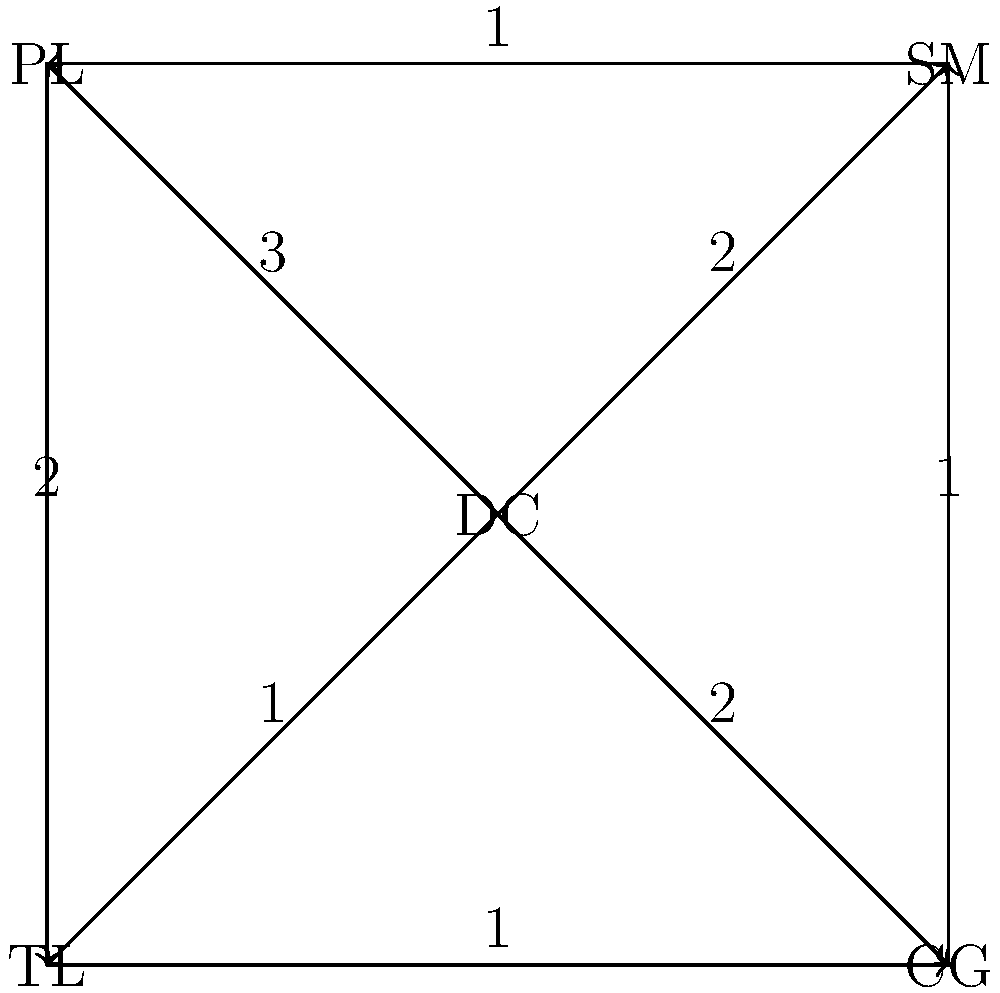In this sociogram representing communication flow in a marching band, nodes represent different sections (DC: Drum Captain, SM: Section Manager, PL: Percussion Lead, TL: Trumpet Lead, CG: Color Guard), and edges represent the frequency of interactions per week. What is the total degree of the Drum Captain (DC) node, and what does this indicate about their role in the band's communication structure? To solve this problem, we need to follow these steps:

1. Understand the concept of degree in graph theory:
   - The degree of a node is the total number of edges connected to it.
   - In a directed graph, we consider both in-degree (edges pointing to the node) and out-degree (edges pointing from the node).

2. Identify the Drum Captain (DC) node:
   - The DC node is at the center of the sociogram.

3. Count the edges connected to the DC node:
   - There are 4 edges originating from the DC node.
   - The numbers on these edges represent the frequency of interactions per week.

4. Calculate the total degree:
   - Out-degree: 4 (edges to SM, PL, TL, and CG)
   - In-degree: 0 (no edges pointing to DC)
   - Total degree = Out-degree + In-degree = 4 + 0 = 4

5. Interpret the result:
   - A high degree (4) indicates that the Drum Captain has direct communication with all other sections.
   - The DC initiates most of the communication (high out-degree, low in-degree).
   - This suggests a central role in coordinating and disseminating information across the band.
Answer: 4; central communication hub 